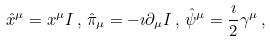<formula> <loc_0><loc_0><loc_500><loc_500>\hat { x } ^ { \mu } = x ^ { \mu } { I } \, , \, \hat { \pi } _ { \mu } = - \imath \partial _ { \mu } { I } \, , \, \hat { \psi } ^ { \mu } = \frac { \imath } { 2 } \gamma ^ { \mu } \, ,</formula> 